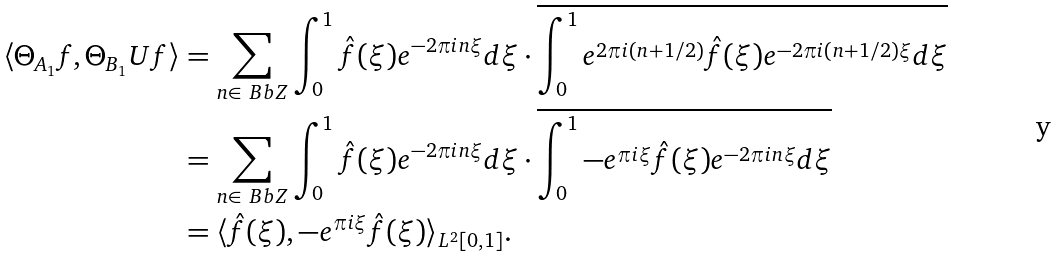Convert formula to latex. <formula><loc_0><loc_0><loc_500><loc_500>\langle \Theta _ { A _ { 1 } } f , \Theta _ { B _ { 1 } } U f \rangle & = \sum _ { n \in \ B b { Z } } \int _ { 0 } ^ { 1 } \hat { f } ( \xi ) e ^ { - 2 \pi i n \xi } d \xi \cdot \overline { \int _ { 0 } ^ { 1 } e ^ { 2 \pi i ( n + 1 / 2 ) } \hat { f } ( \xi ) e ^ { - 2 \pi i ( n + 1 / 2 ) \xi } d \xi } \\ & = \sum _ { n \in \ B b { Z } } \int _ { 0 } ^ { 1 } \hat { f } ( \xi ) e ^ { - 2 \pi i n \xi } d \xi \cdot \overline { \int _ { 0 } ^ { 1 } - e ^ { \pi i \xi } \hat { f } ( \xi ) e ^ { - 2 \pi i n \xi } d \xi } \\ & = \langle \hat { f } ( \xi ) , - e ^ { \pi i \xi } \hat { f } ( \xi ) \rangle _ { L ^ { 2 } { [ 0 , 1 ] } } .</formula> 